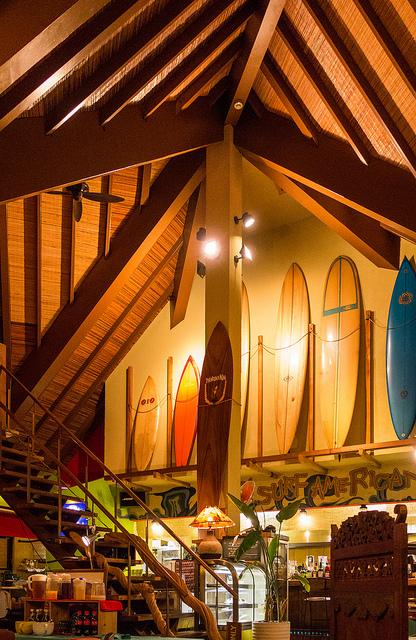Does this store have a second story?
Give a very brief answer. Yes. What is on the wall?
Short answer required. Surfboards. What is the ceiling made of?
Keep it brief. Wood. 